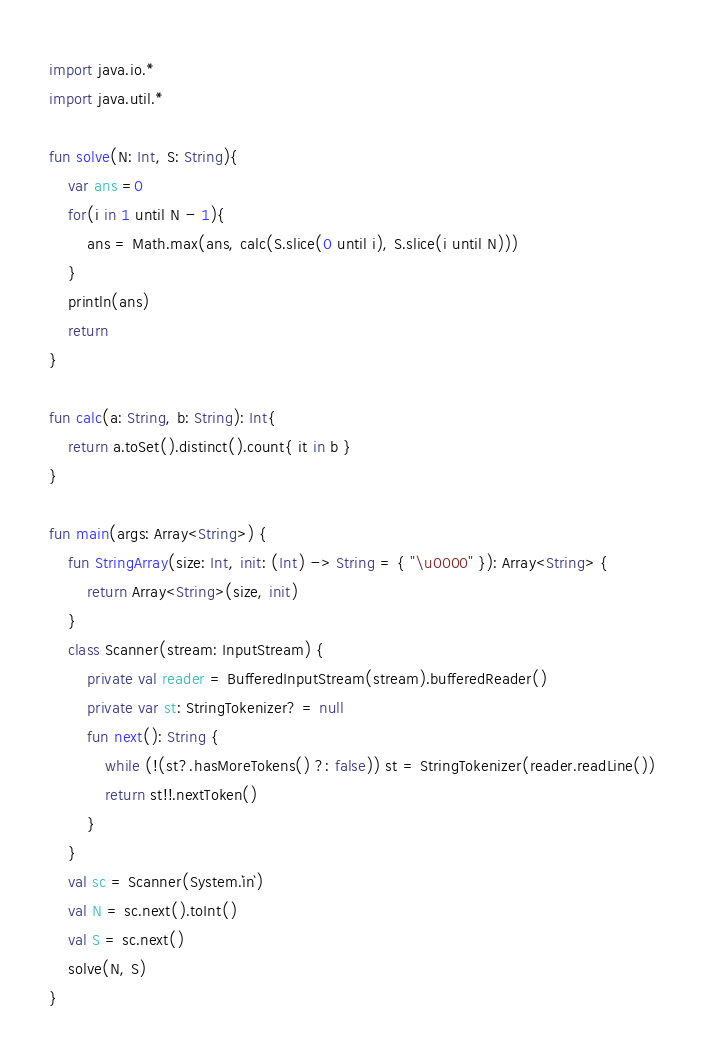<code> <loc_0><loc_0><loc_500><loc_500><_Kotlin_>import java.io.*
import java.util.*

fun solve(N: Int, S: String){
    var ans =0
    for(i in 1 until N - 1){
        ans = Math.max(ans, calc(S.slice(0 until i), S.slice(i until N)))
    }
    println(ans)
    return
}

fun calc(a: String, b: String): Int{
    return a.toSet().distinct().count{ it in b }
}

fun main(args: Array<String>) {
    fun StringArray(size: Int, init: (Int) -> String = { "\u0000" }): Array<String> {
        return Array<String>(size, init)
    }
    class Scanner(stream: InputStream) {
        private val reader = BufferedInputStream(stream).bufferedReader()
        private var st: StringTokenizer? = null
        fun next(): String {
            while (!(st?.hasMoreTokens() ?: false)) st = StringTokenizer(reader.readLine())
            return st!!.nextToken()
        }
    }
    val sc = Scanner(System.`in`)
    val N = sc.next().toInt()
    val S = sc.next()
    solve(N, S)
}

</code> 